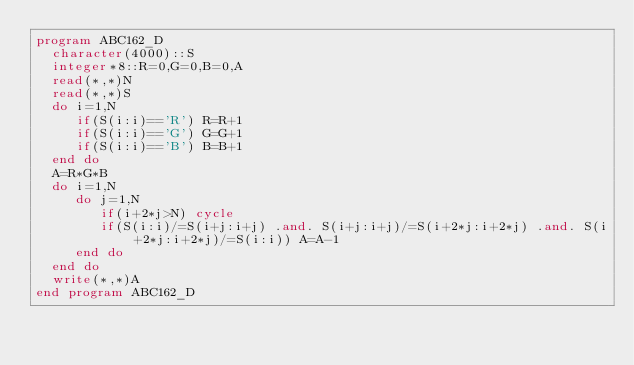<code> <loc_0><loc_0><loc_500><loc_500><_FORTRAN_>program ABC162_D
  character(4000)::S
  integer*8::R=0,G=0,B=0,A
  read(*,*)N
  read(*,*)S
  do i=1,N
     if(S(i:i)=='R') R=R+1
     if(S(i:i)=='G') G=G+1
     if(S(i:i)=='B') B=B+1
  end do
  A=R*G*B
  do i=1,N
     do j=1,N
        if(i+2*j>N) cycle
        if(S(i:i)/=S(i+j:i+j) .and. S(i+j:i+j)/=S(i+2*j:i+2*j) .and. S(i+2*j:i+2*j)/=S(i:i)) A=A-1
     end do
  end do
  write(*,*)A
end program ABC162_D</code> 